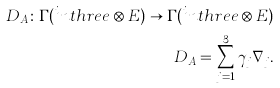Convert formula to latex. <formula><loc_0><loc_0><loc_500><loc_500>D _ { A } \colon \Gamma ( ^ { i } n t h r e e \otimes E ) \rightarrow \Gamma ( ^ { i } n t h r e e \otimes E ) \\ D _ { A } = \sum _ { j = 1 } ^ { 3 } \gamma _ { j } \nabla _ { j } .</formula> 